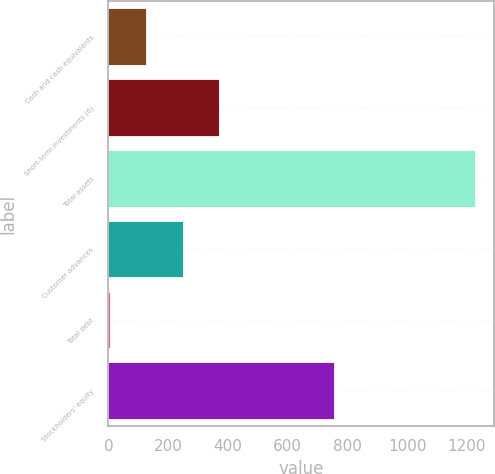Convert chart. <chart><loc_0><loc_0><loc_500><loc_500><bar_chart><fcel>Cash and cash equivalents<fcel>Short-term investments (6)<fcel>Total assets<fcel>Customer advances<fcel>Total debt<fcel>Stockholders' equity<nl><fcel>126.59<fcel>371.37<fcel>1228.1<fcel>248.98<fcel>4.2<fcel>755.9<nl></chart> 